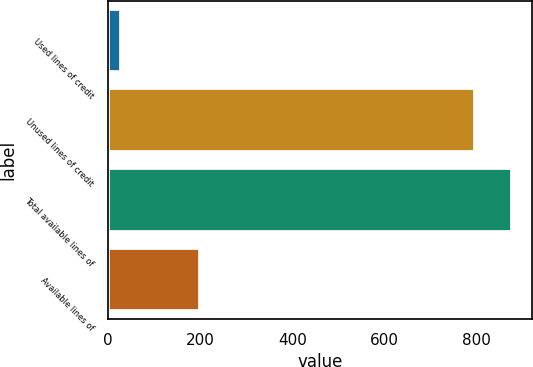<chart> <loc_0><loc_0><loc_500><loc_500><bar_chart><fcel>Used lines of credit<fcel>Unused lines of credit<fcel>Total available lines of<fcel>Available lines of<nl><fcel>27.2<fcel>797.6<fcel>877.36<fcel>200.1<nl></chart> 